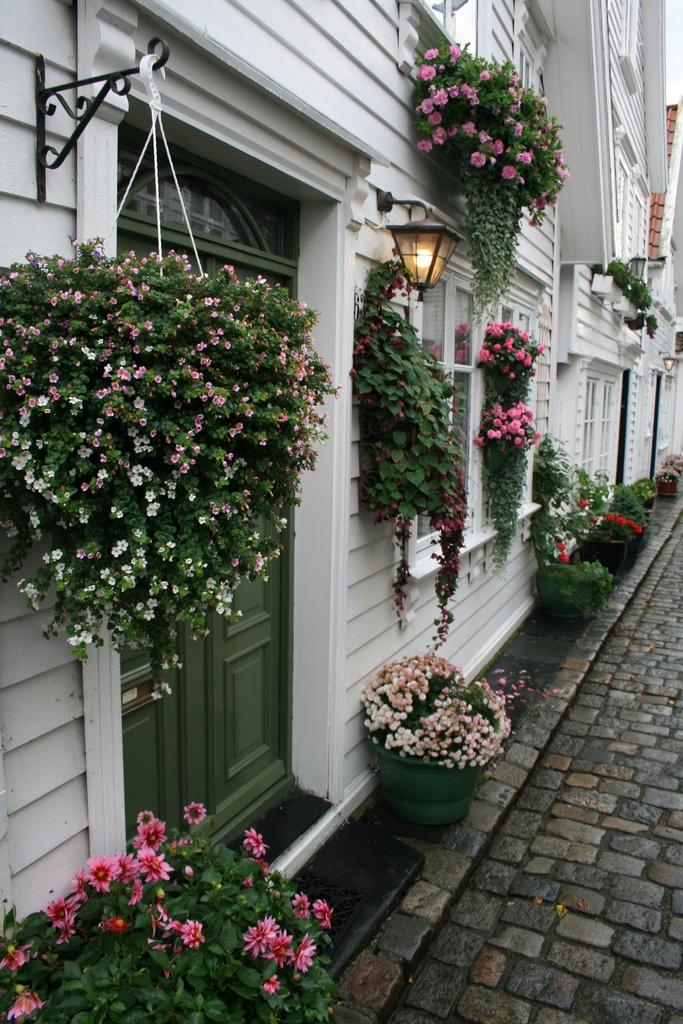What structure is located on the left side of the image? There is a building on the left side of the image. What type of vegetation can be seen in the image? There are flower plants in flower pots in the image. What feature of the building is mentioned in the facts? The building has glass windows. How many branches can be seen holding the flower plants in the image? There is no mention of branches in the image; the flower plants are in flower pots. What type of grip does the building have on the flower plants? The building does not have a grip on the flower plants; they are in separate flower pots. 